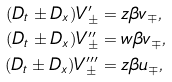<formula> <loc_0><loc_0><loc_500><loc_500>( D _ { t } \pm D _ { x } ) V ^ { \prime } _ { \pm } & = z \beta v _ { \mp } , \\ ( D _ { t } \pm D _ { x } ) V ^ { \prime \prime } _ { \pm } & = w \beta v _ { \mp } , \\ ( D _ { t } \pm D _ { x } ) V ^ { \prime \prime \prime } _ { \pm } & = z \beta u _ { \mp } ,</formula> 